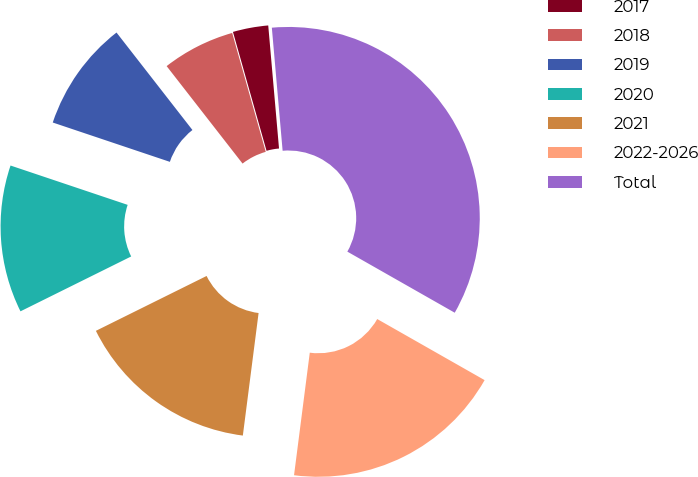Convert chart to OTSL. <chart><loc_0><loc_0><loc_500><loc_500><pie_chart><fcel>2017<fcel>2018<fcel>2019<fcel>2020<fcel>2021<fcel>2022-2026<fcel>Total<nl><fcel>2.99%<fcel>6.15%<fcel>9.31%<fcel>12.48%<fcel>15.64%<fcel>18.8%<fcel>34.62%<nl></chart> 